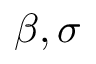Convert formula to latex. <formula><loc_0><loc_0><loc_500><loc_500>\beta , \sigma</formula> 